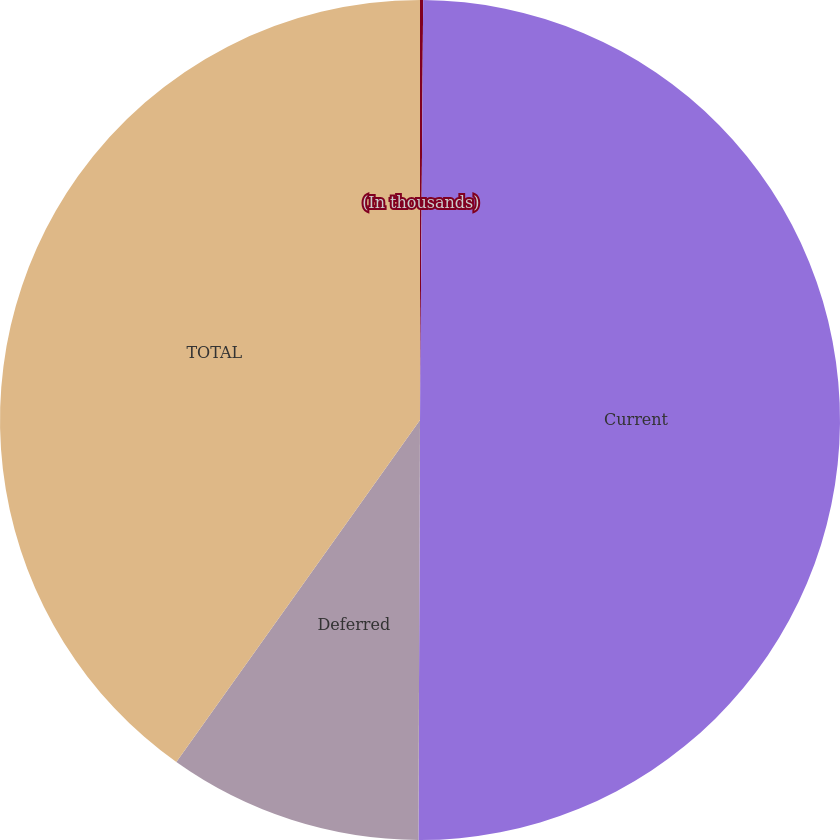<chart> <loc_0><loc_0><loc_500><loc_500><pie_chart><fcel>(In thousands)<fcel>Current<fcel>Deferred<fcel>TOTAL<nl><fcel>0.12%<fcel>49.94%<fcel>9.79%<fcel>40.15%<nl></chart> 